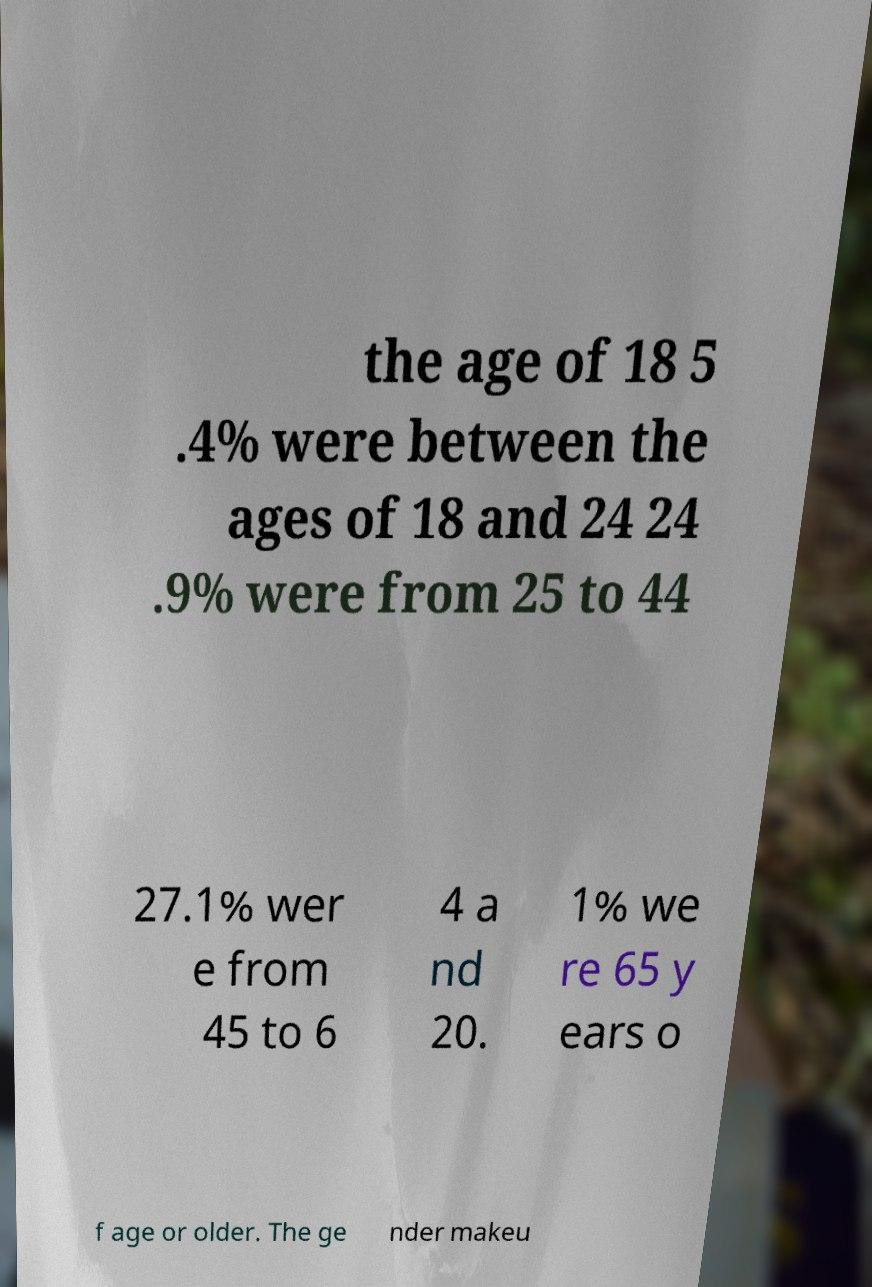I need the written content from this picture converted into text. Can you do that? the age of 18 5 .4% were between the ages of 18 and 24 24 .9% were from 25 to 44 27.1% wer e from 45 to 6 4 a nd 20. 1% we re 65 y ears o f age or older. The ge nder makeu 